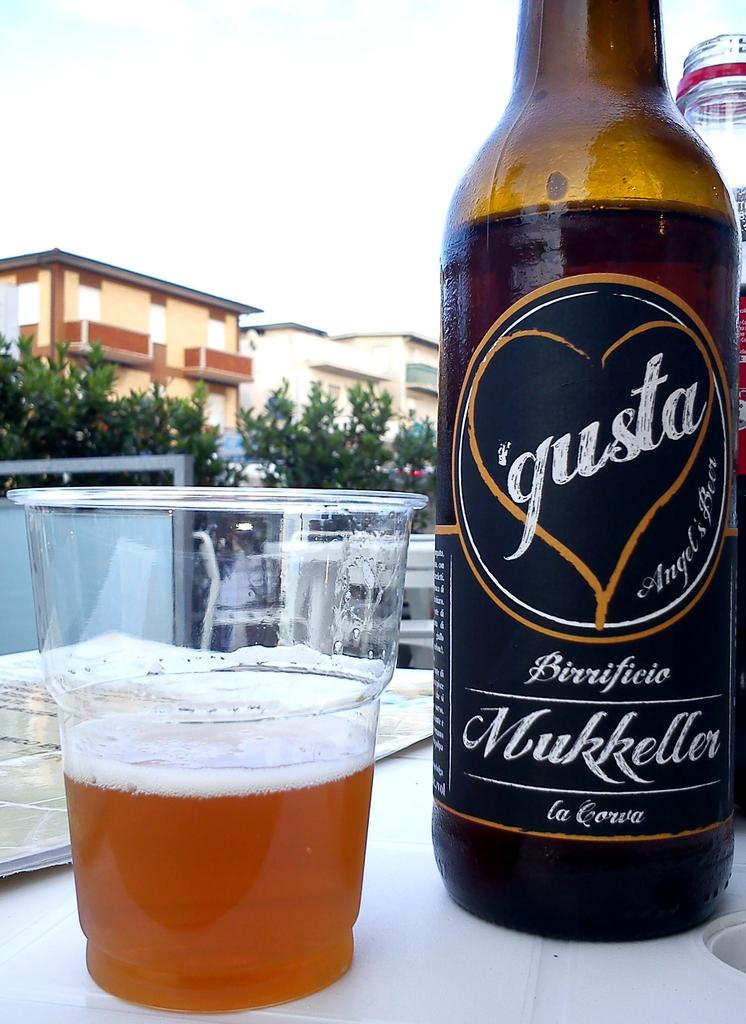What is contained in the bottle that is visible in the image? There is a drink in the bottle in the image. What is the glass used for in the image? The glass is likely used for drinking the same type of drink as the one in the bottle. On what surface are the bottle and glass placed? The bottle and glass are placed on some floor in the image. What can be seen in the background of the image? There is a building, a tree, and the sky visible in the background of the image. What type of cheese is being used to stamp the country's flag on the glass in the image? There is no cheese or stamping of a flag present in the image. The image only shows a bottle with a drink and a glass placed on some floor, with a building, a tree, and the sky visible in the background. 